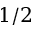Convert formula to latex. <formula><loc_0><loc_0><loc_500><loc_500>1 / 2</formula> 